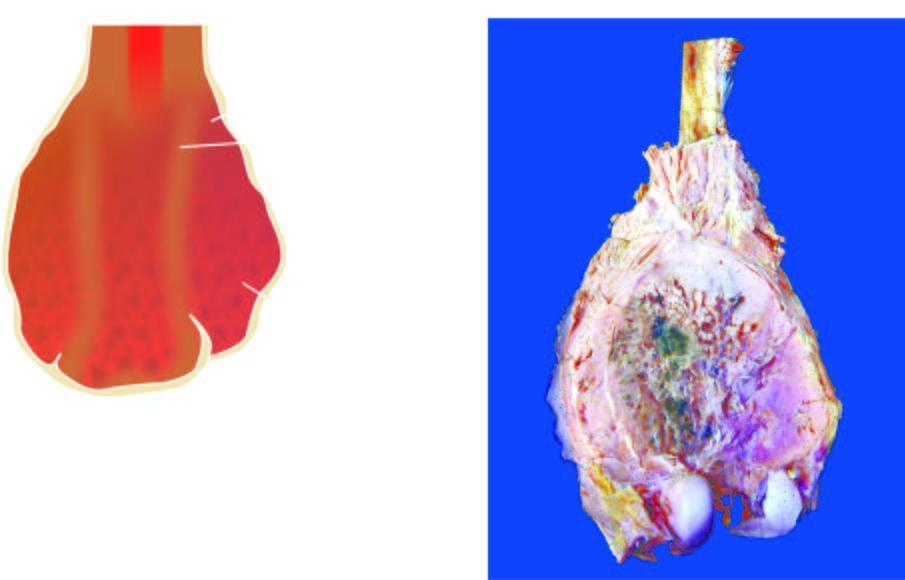what is grey-white with areas of haemorrhage and necrosis?
Answer the question using a single word or phrase. A bulky expanded tumour in the region of metaphysis sparing the epiphyseal cartilage 